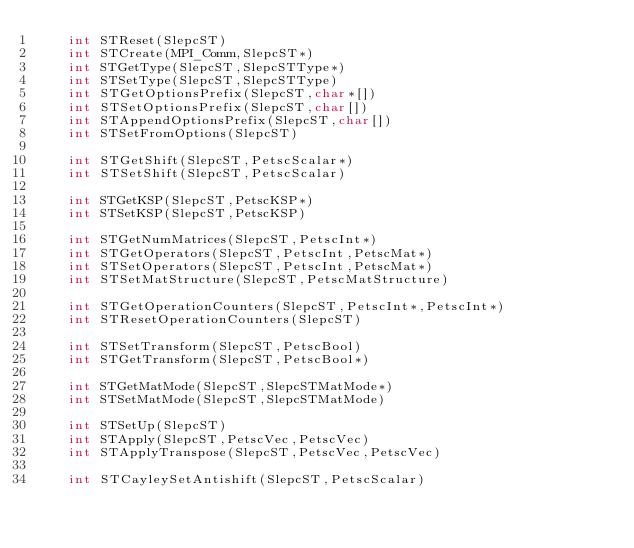Convert code to text. <code><loc_0><loc_0><loc_500><loc_500><_Cython_>    int STReset(SlepcST)
    int STCreate(MPI_Comm,SlepcST*)
    int STGetType(SlepcST,SlepcSTType*)
    int STSetType(SlepcST,SlepcSTType)
    int STGetOptionsPrefix(SlepcST,char*[])
    int STSetOptionsPrefix(SlepcST,char[])
    int STAppendOptionsPrefix(SlepcST,char[])
    int STSetFromOptions(SlepcST)

    int STGetShift(SlepcST,PetscScalar*)
    int STSetShift(SlepcST,PetscScalar)

    int STGetKSP(SlepcST,PetscKSP*)
    int STSetKSP(SlepcST,PetscKSP)

    int STGetNumMatrices(SlepcST,PetscInt*)
    int STGetOperators(SlepcST,PetscInt,PetscMat*)
    int STSetOperators(SlepcST,PetscInt,PetscMat*)
    int STSetMatStructure(SlepcST,PetscMatStructure)

    int STGetOperationCounters(SlepcST,PetscInt*,PetscInt*)
    int STResetOperationCounters(SlepcST)

    int STSetTransform(SlepcST,PetscBool)
    int STGetTransform(SlepcST,PetscBool*)

    int STGetMatMode(SlepcST,SlepcSTMatMode*)
    int STSetMatMode(SlepcST,SlepcSTMatMode)

    int STSetUp(SlepcST)
    int STApply(SlepcST,PetscVec,PetscVec)
    int STApplyTranspose(SlepcST,PetscVec,PetscVec)

    int STCayleySetAntishift(SlepcST,PetscScalar)
</code> 